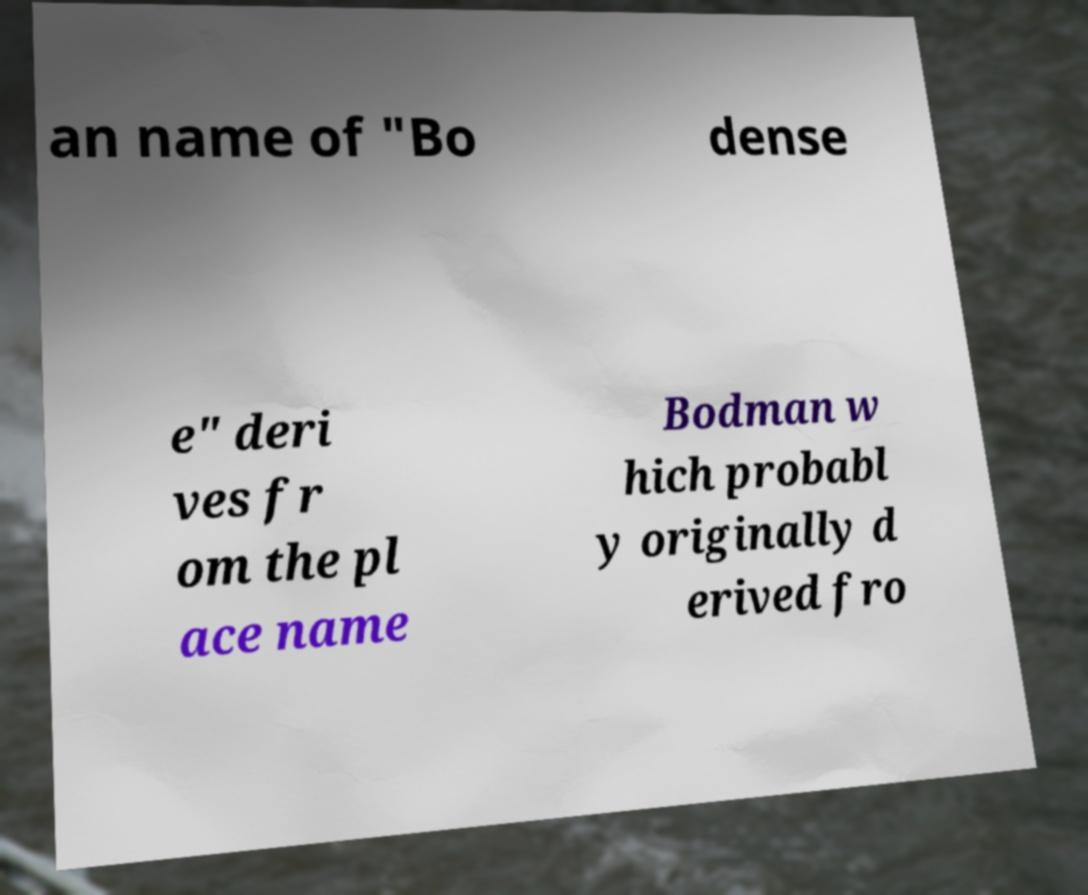Could you assist in decoding the text presented in this image and type it out clearly? an name of "Bo dense e" deri ves fr om the pl ace name Bodman w hich probabl y originally d erived fro 